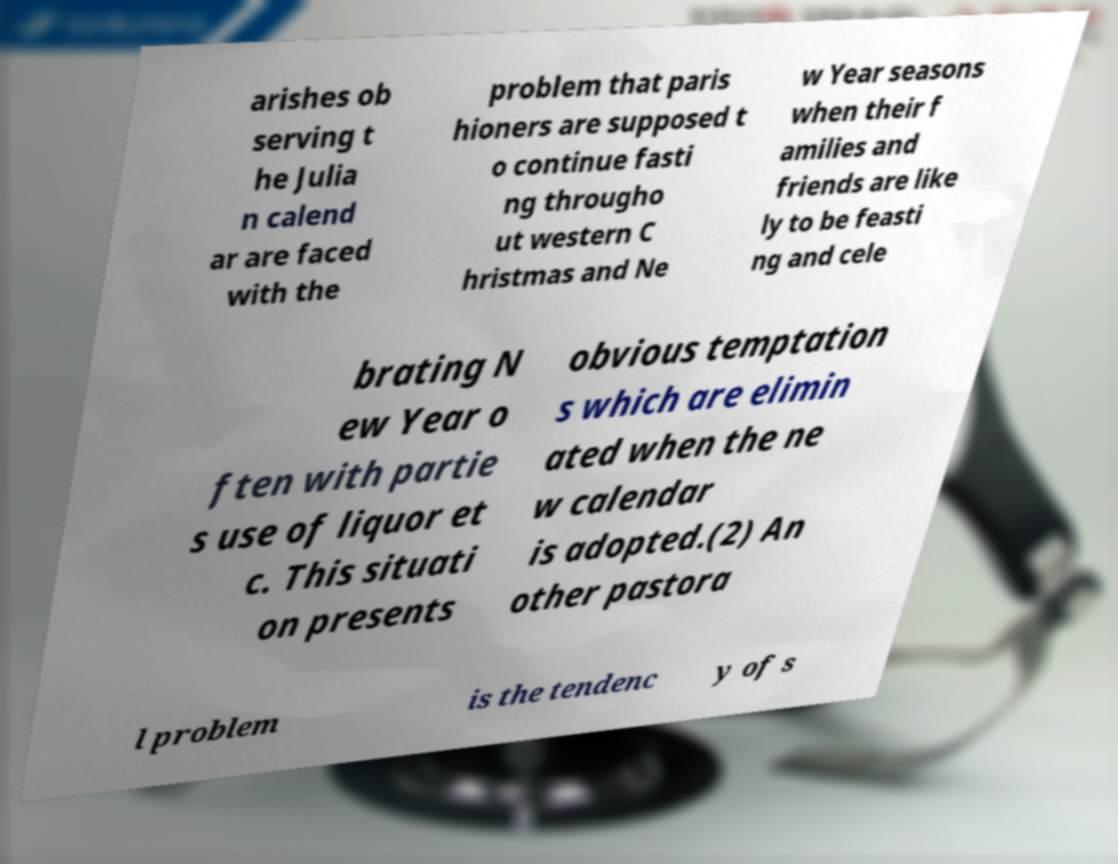What messages or text are displayed in this image? I need them in a readable, typed format. arishes ob serving t he Julia n calend ar are faced with the problem that paris hioners are supposed t o continue fasti ng througho ut western C hristmas and Ne w Year seasons when their f amilies and friends are like ly to be feasti ng and cele brating N ew Year o ften with partie s use of liquor et c. This situati on presents obvious temptation s which are elimin ated when the ne w calendar is adopted.(2) An other pastora l problem is the tendenc y of s 